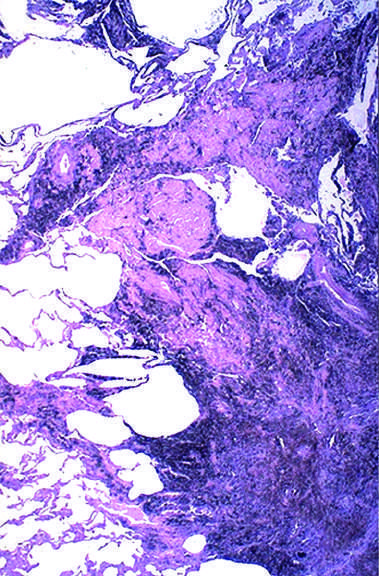s a large amount of black pigment associated with fibrosis?
Answer the question using a single word or phrase. Yes 